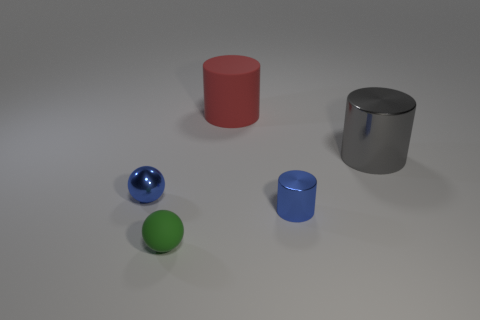Can you describe the shapes and their colors visible in the image? Certainly! The image displays a variety of geometric shapes in different colors. We see a shiny blue sphere, a matte green sphere, and two cylinders – one is a matte red and the other a reflective silver. Additionally, there is a reflective blue cylinder with a top that is not visible, suggesting it may be a cup or container of sorts. 